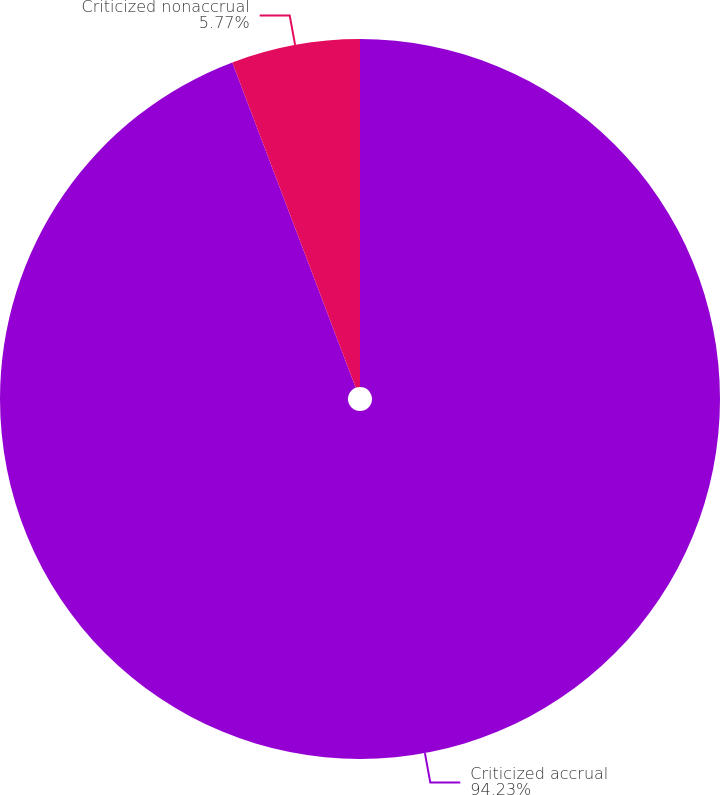Convert chart. <chart><loc_0><loc_0><loc_500><loc_500><pie_chart><fcel>Criticized accrual<fcel>Criticized nonaccrual<nl><fcel>94.23%<fcel>5.77%<nl></chart> 